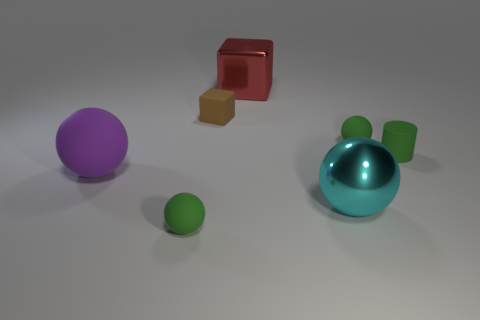How many purple matte spheres are the same size as the red metal object?
Offer a terse response. 1. What number of purple objects are right of the matte sphere that is behind the small green rubber cylinder?
Provide a short and direct response. 0. There is a big shiny object behind the small matte cylinder; is it the same color as the rubber cylinder?
Give a very brief answer. No. There is a red thing that is behind the green ball right of the shiny cube; are there any small matte blocks to the right of it?
Provide a succinct answer. No. The large object that is both behind the big cyan metallic sphere and to the right of the brown matte object has what shape?
Provide a short and direct response. Cube. Is there a thing that has the same color as the big metal cube?
Your answer should be very brief. No. What is the color of the object that is to the left of the tiny matte thing that is left of the small brown thing?
Offer a very short reply. Purple. What is the size of the green rubber thing on the right side of the tiny green rubber sphere behind the small green ball in front of the green matte cylinder?
Provide a short and direct response. Small. Do the cylinder and the small object that is in front of the cyan metallic sphere have the same material?
Give a very brief answer. Yes. There is a brown cube that is made of the same material as the purple object; what size is it?
Make the answer very short. Small. 